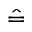Convert formula to latex. <formula><loc_0><loc_0><loc_500><loc_500>\hat { = }</formula> 